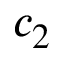Convert formula to latex. <formula><loc_0><loc_0><loc_500><loc_500>c _ { 2 }</formula> 